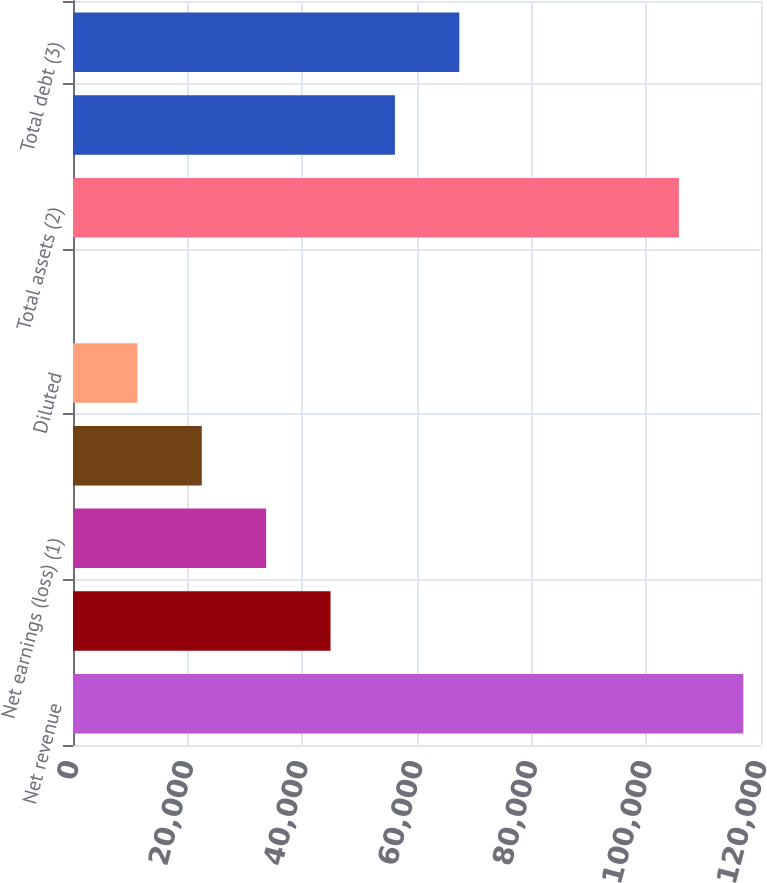<chart> <loc_0><loc_0><loc_500><loc_500><bar_chart><fcel>Net revenue<fcel>Earnings (loss) from<fcel>Net earnings (loss) (1)<fcel>Basic<fcel>Diluted<fcel>Cash dividends declared per<fcel>Total assets (2)<fcel>Long-term debt<fcel>Total debt (3)<nl><fcel>116906<fcel>44919.5<fcel>33689.8<fcel>22460<fcel>11230.3<fcel>0.55<fcel>105676<fcel>56149.3<fcel>67379<nl></chart> 